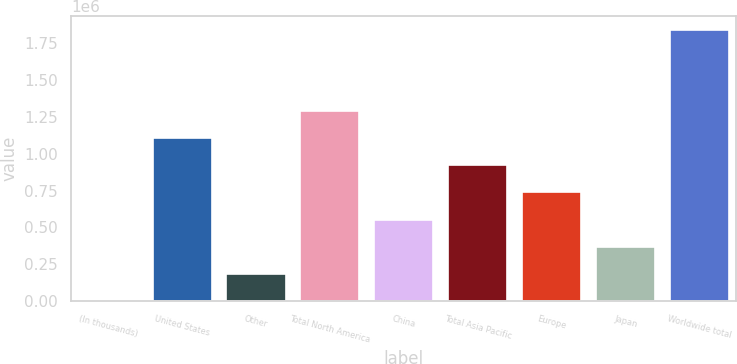Convert chart. <chart><loc_0><loc_0><loc_500><loc_500><bar_chart><fcel>(In thousands)<fcel>United States<fcel>Other<fcel>Total North America<fcel>China<fcel>Total Asia Pacific<fcel>Europe<fcel>Japan<fcel>Worldwide total<nl><fcel>2008<fcel>1.10563e+06<fcel>185944<fcel>1.28956e+06<fcel>553817<fcel>921690<fcel>737754<fcel>369881<fcel>1.84137e+06<nl></chart> 